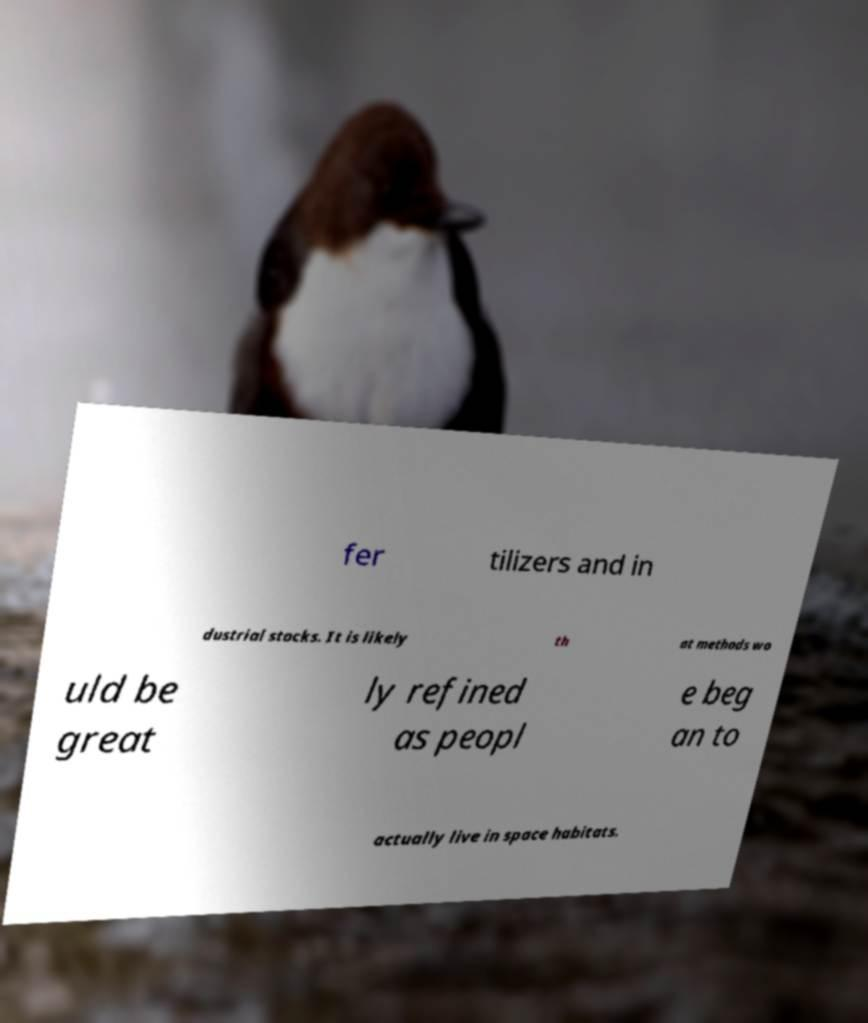Could you assist in decoding the text presented in this image and type it out clearly? fer tilizers and in dustrial stocks. It is likely th at methods wo uld be great ly refined as peopl e beg an to actually live in space habitats. 